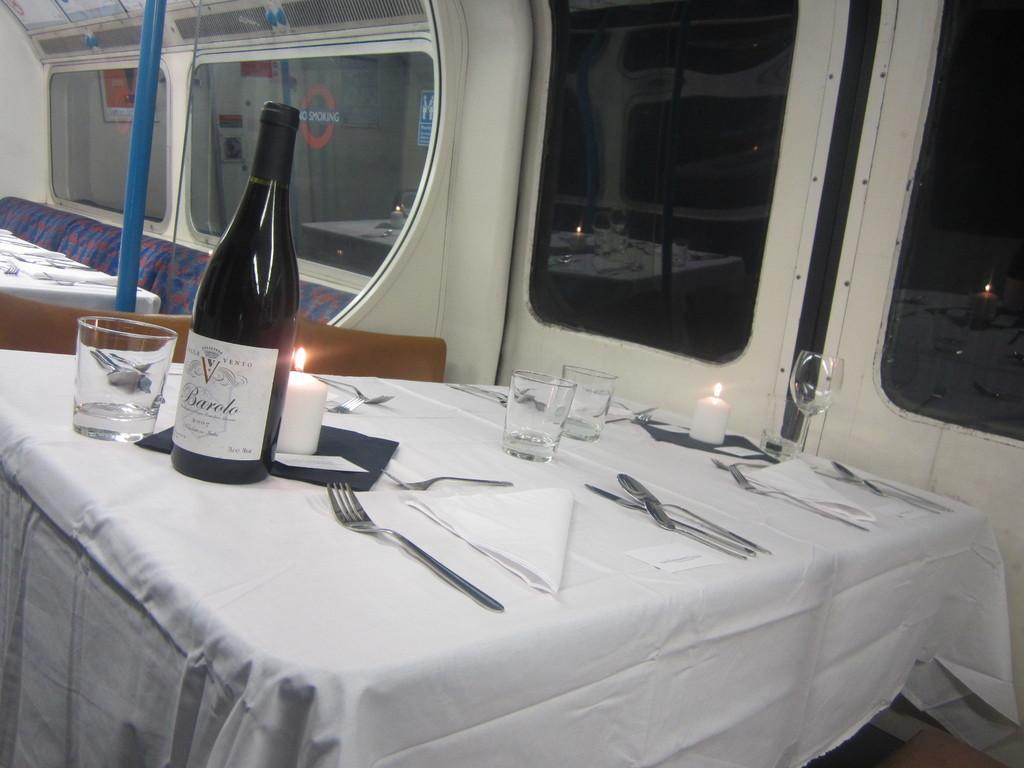What is the main piece of furniture in the image? There is a table in the image. What items can be seen on the table? There are tissues, spoons, glasses, two candles, and a bottle on the table. What type of windows can be seen in the background of the image? There are glass windows in the background of the image. What is visible in the background of the image besides the windows? There is a vehicle visible in the background of the image. What type of doctor is standing near the vehicle in the background of the image? There is no doctor present in the image, and therefore no such person can be observed. 